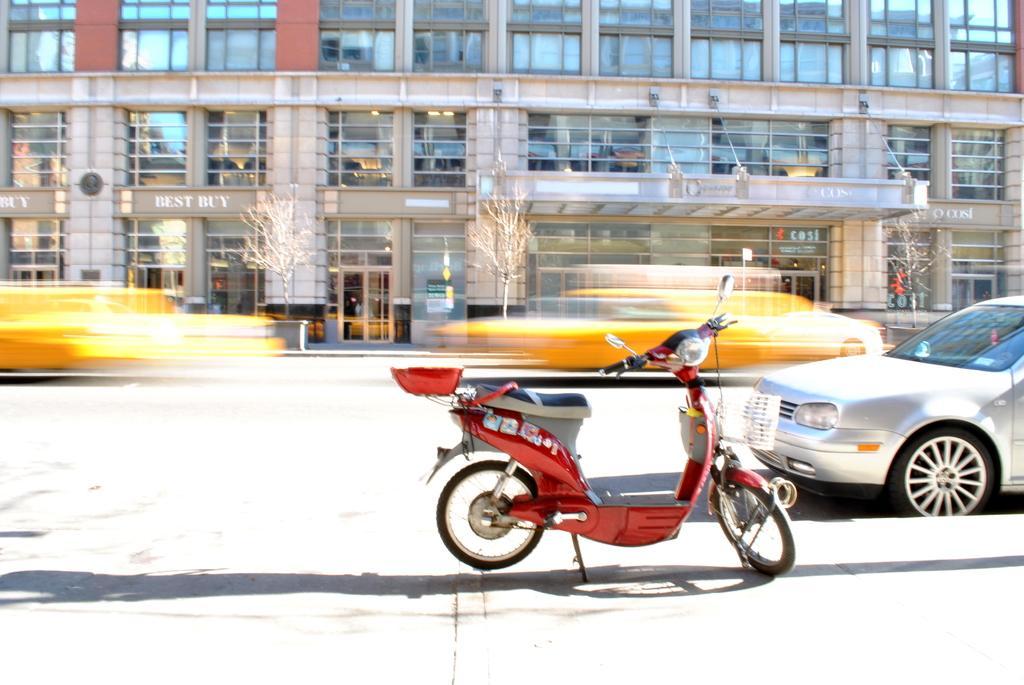How would you summarize this image in a sentence or two? In this image in the foreground there are few vehicles visible on the road, at the top there is a building, in front of building there are trees visible. 